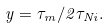Convert formula to latex. <formula><loc_0><loc_0><loc_500><loc_500>y = \tau _ { m } / 2 \tau _ { N i } .</formula> 